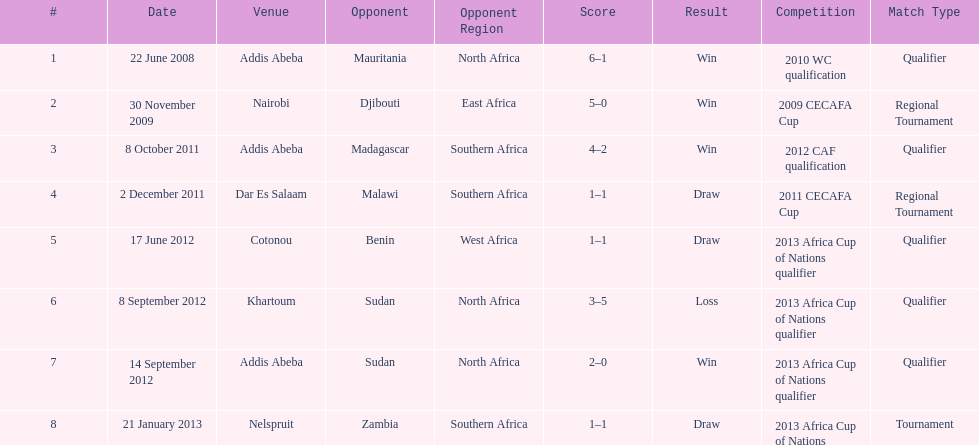True or false? in comparison, the ethiopian national team has more draws than wins. False. 